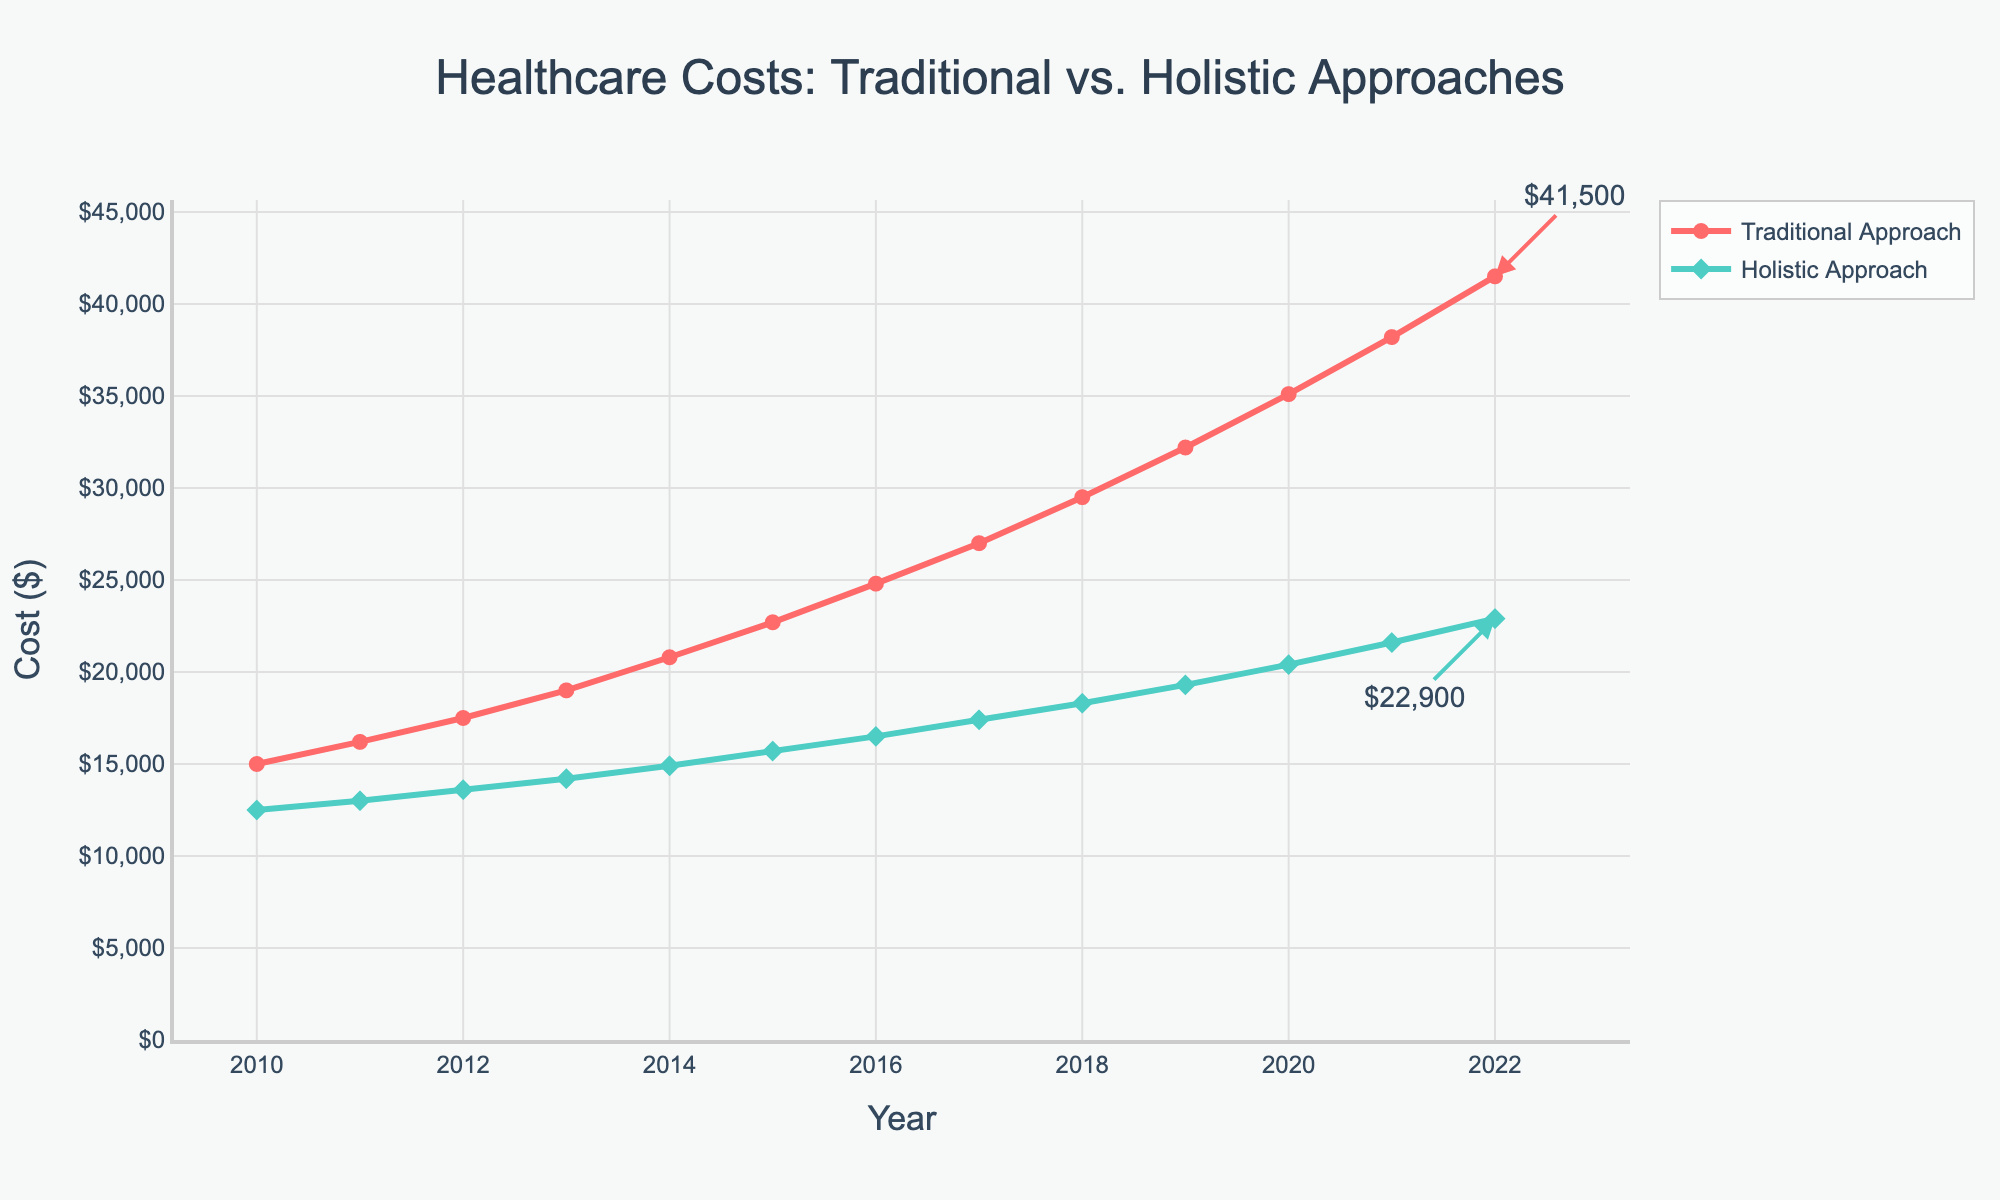Which year shows the highest cost for the traditional approach? Observing the line chart, the highest cost for the traditional approach is at the end of the timeline which is the year 2022 with the highest plotted point on the red line.
Answer: 2022 How much more expensive is the traditional approach compared to the holistic approach in 2022? The annotation on the figure shows the cost for the traditional approach is $41,500 and for the holistic approach is $22,900 in 2022. Subtracting these values, $41,500 - $22,900 gives the difference.
Answer: $18,600 What is the overall trend for both healthcare costs from 2010 to 2022? Both lines (red for traditional and green for holistic) show an upward trajectory which indicates increasing costs over the years from 2010 to 2022.
Answer: Increasing In which year did the holistic approach first cost more than $15,000? Observing the green line (holistic approach), it crosses the $15,000 mark in 2015.
Answer: 2015 Compare the costs between traditional and holistic approaches in 2015. How much more did the traditional approach cost? In 2015, the figure shows $22,700 for the traditional approach and $15,700 for the holistic approach. Subtracting these, $22,700 - $15,700, gives the cost difference.
Answer: $7,000 What is the percentage increase in the traditional approach cost from 2010 to 2022? The cost in 2010 is $15,000, and in 2022, it is $41,500. The percentage increase can be calculated as [(41,500 - 15,000) / 15,000] * 100. [(26,500) / 15,000] * 100 = 176.67%.
Answer: 176.67% What is the average annual increase in cost for the holistic approach from 2010 to 2022? The cost for the holistic approach in 2010 is $12,500 and in 2022 is $22,900. The total increase is $22,900 - $12,500 = $10,400 over 12 years. The average annual increase is $10,400 / 12.
Answer: $866.67 In which year did the cost for the traditional approach exceed $30,000? Observing the red line (traditional approach), it crosses the $30,000 mark in 2019.
Answer: 2019 